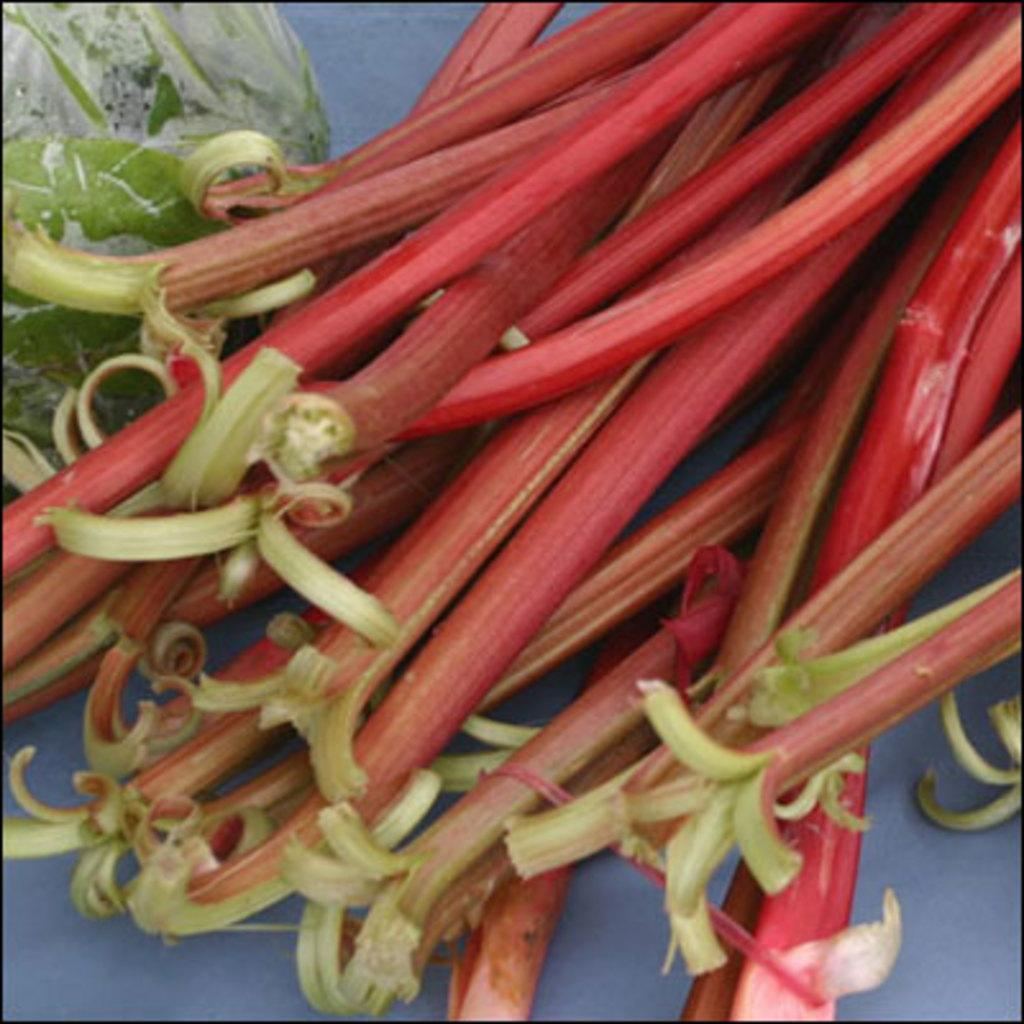What type of plants are in the image? There are garden rhubarbs in the image. What is the color of the surface the plants are on? The surface they are on is white colored. How do the garden rhubarbs compare to the pies in the image? There are no pies present in the image, so a comparison cannot be made. 